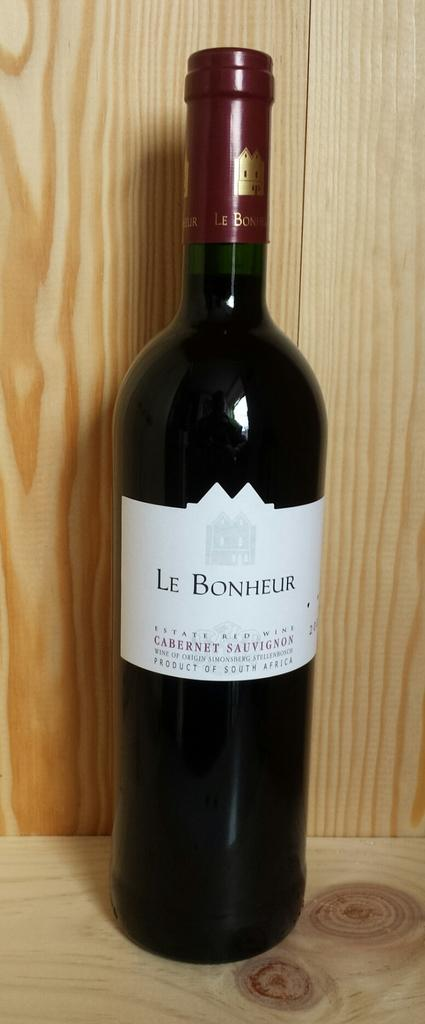<image>
Share a concise interpretation of the image provided. A bottle of red wine has the brand name Le Bonheur on the label. 